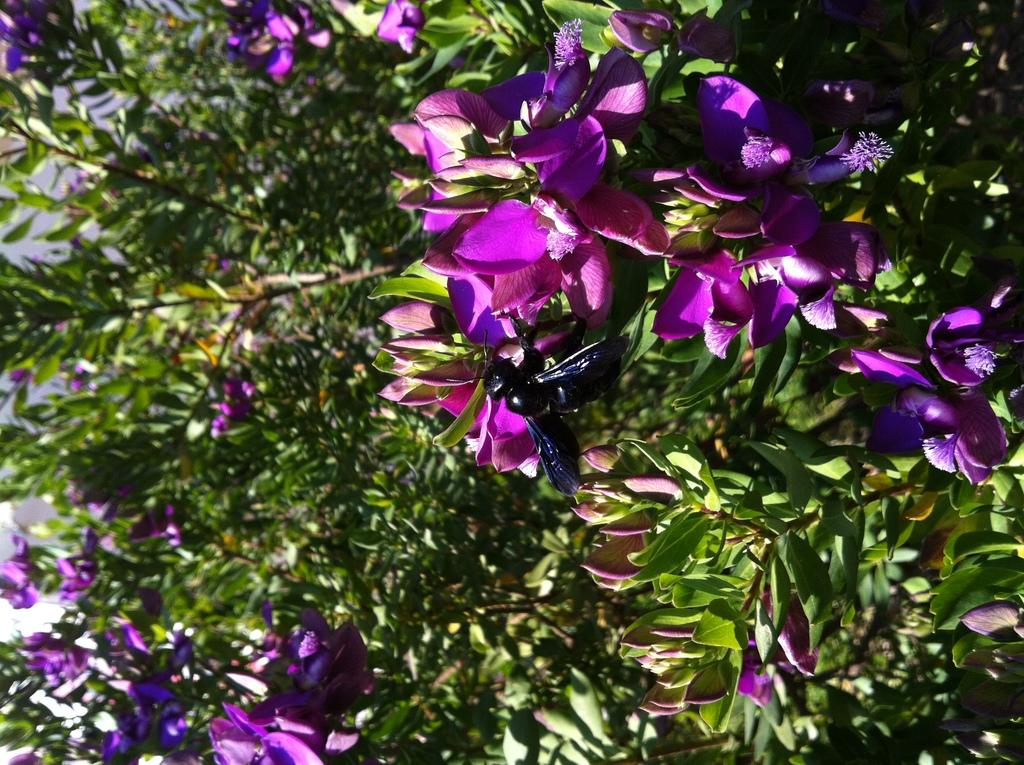What is the main subject of the image? The main subject of the image is a fly on a flower. What can be seen in the background of the image? There are trees visible in the background of the image. What advice does the fly give to the trees in the image? There is no indication in the image that the fly is giving advice to the trees, as the fly is simply perched on a flower. 